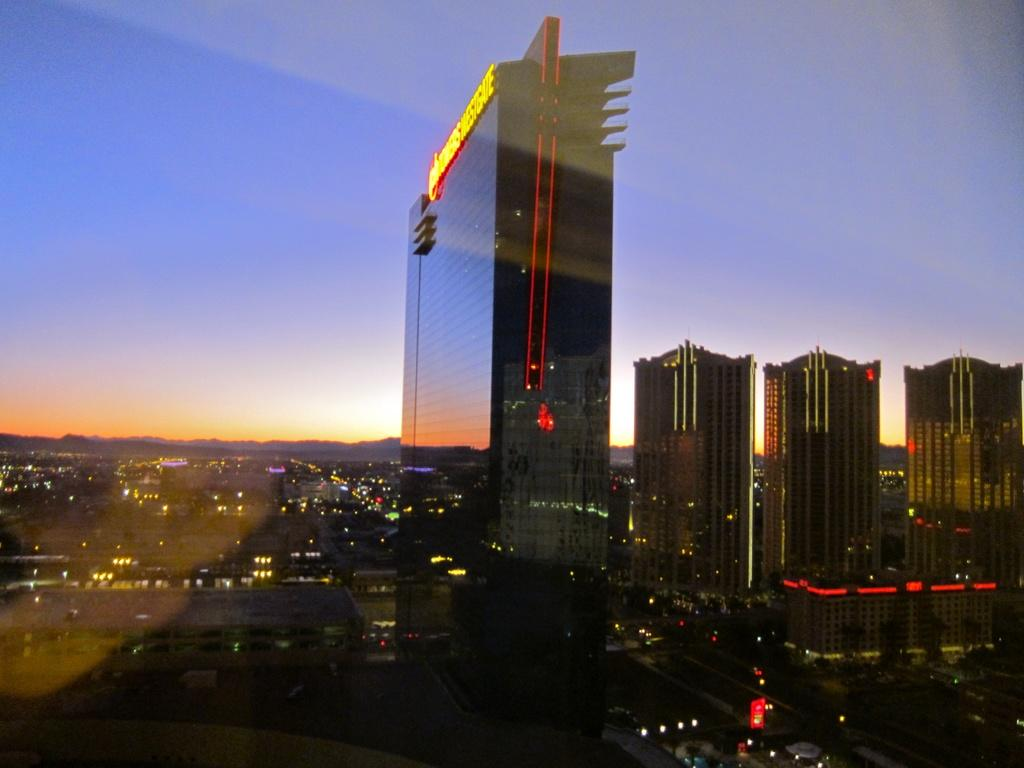What type of location is depicted in the image? The image shows a big street. What can be seen along the street in the image? There are many buildings visible in the image. What color is the kite flying over the street in the image? There is no kite visible in the image. What type of medical facility is located on the street in the image? There is no hospital mentioned or visible in the image. 